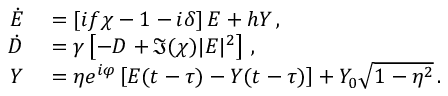<formula> <loc_0><loc_0><loc_500><loc_500>\begin{array} { r l } { \dot { E } } & = \left [ i f \chi - 1 - i \delta \right ] E + h Y \, , } \\ { \dot { D } } & = \gamma \left [ - D + \Im ( \chi ) | E | ^ { 2 } \right ] \, , } \\ { Y } & = \eta e ^ { i \varphi } \left [ E ( t - \tau ) - Y ( t - \tau ) \right ] + Y _ { 0 } \sqrt { 1 - \eta ^ { 2 } } \, . } \end{array}</formula> 